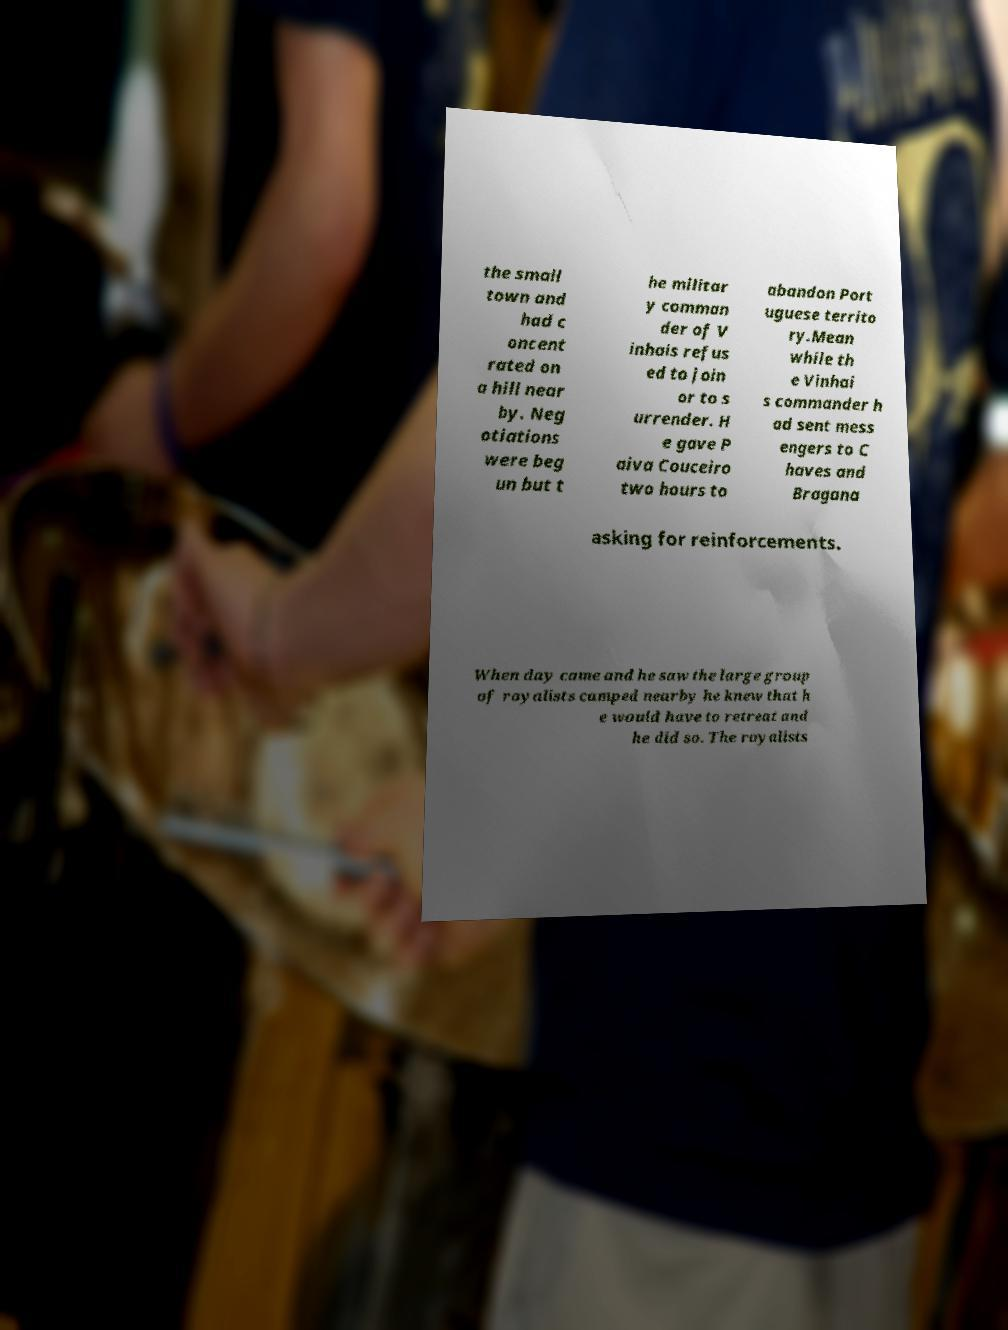I need the written content from this picture converted into text. Can you do that? the small town and had c oncent rated on a hill near by. Neg otiations were beg un but t he militar y comman der of V inhais refus ed to join or to s urrender. H e gave P aiva Couceiro two hours to abandon Port uguese territo ry.Mean while th e Vinhai s commander h ad sent mess engers to C haves and Bragana asking for reinforcements. When day came and he saw the large group of royalists camped nearby he knew that h e would have to retreat and he did so. The royalists 